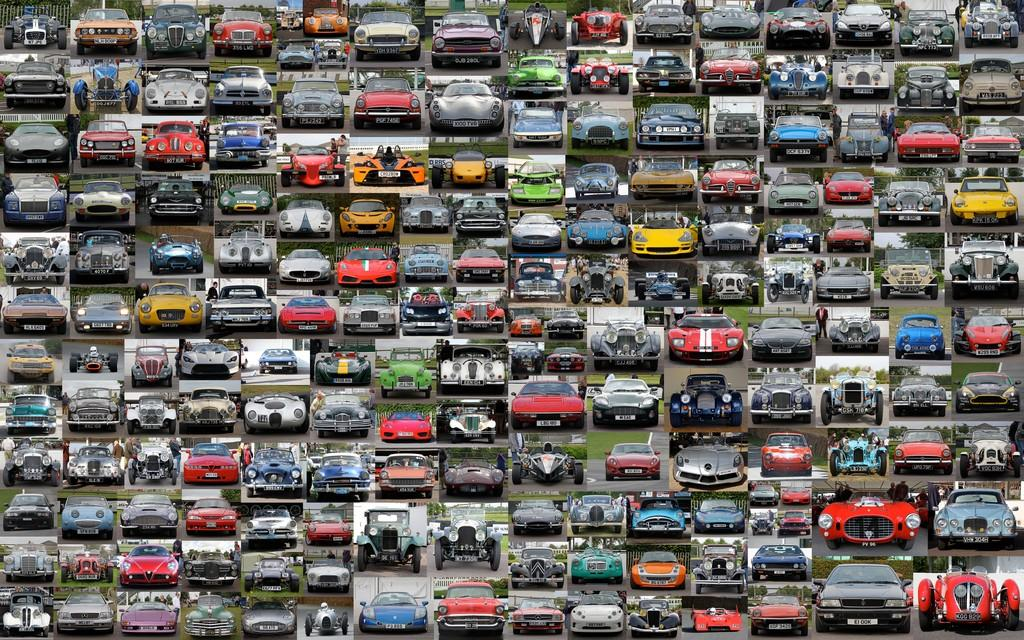What type of visual composition is the image? The image is a collage of pictures. What subjects are featured in the collage? There are cars in the collage. Can you see a lake in the collage? There is no lake present in the collage; it only features cars. What type of creature can be seen interacting with the cars in the collage? There are no creatures present in the collage; it only features cars. 